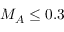Convert formula to latex. <formula><loc_0><loc_0><loc_500><loc_500>M _ { A } \leq 0 . 3</formula> 